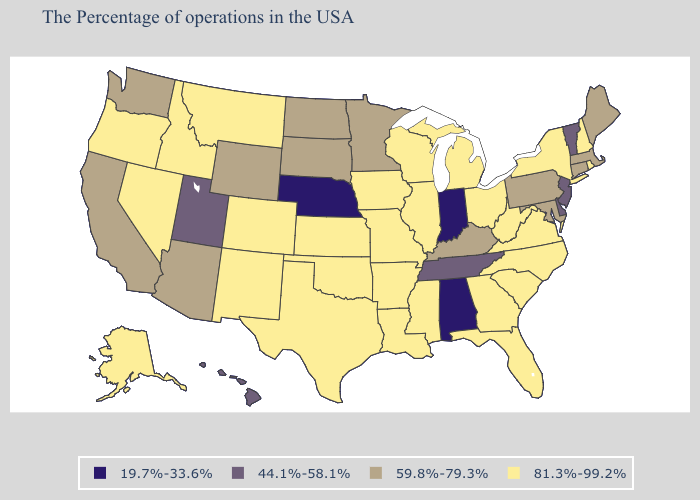Name the states that have a value in the range 59.8%-79.3%?
Keep it brief. Maine, Massachusetts, Connecticut, Maryland, Pennsylvania, Kentucky, Minnesota, South Dakota, North Dakota, Wyoming, Arizona, California, Washington. What is the highest value in states that border California?
Quick response, please. 81.3%-99.2%. Name the states that have a value in the range 44.1%-58.1%?
Be succinct. Vermont, New Jersey, Delaware, Tennessee, Utah, Hawaii. Does the first symbol in the legend represent the smallest category?
Be succinct. Yes. What is the value of Tennessee?
Be succinct. 44.1%-58.1%. Is the legend a continuous bar?
Concise answer only. No. Does the first symbol in the legend represent the smallest category?
Be succinct. Yes. Name the states that have a value in the range 19.7%-33.6%?
Short answer required. Indiana, Alabama, Nebraska. Name the states that have a value in the range 44.1%-58.1%?
Give a very brief answer. Vermont, New Jersey, Delaware, Tennessee, Utah, Hawaii. What is the value of Hawaii?
Keep it brief. 44.1%-58.1%. Does Utah have a higher value than Missouri?
Give a very brief answer. No. Does Kentucky have the highest value in the USA?
Concise answer only. No. Does Montana have the highest value in the West?
Concise answer only. Yes. Does Missouri have a lower value than Connecticut?
Give a very brief answer. No. Which states have the highest value in the USA?
Concise answer only. Rhode Island, New Hampshire, New York, Virginia, North Carolina, South Carolina, West Virginia, Ohio, Florida, Georgia, Michigan, Wisconsin, Illinois, Mississippi, Louisiana, Missouri, Arkansas, Iowa, Kansas, Oklahoma, Texas, Colorado, New Mexico, Montana, Idaho, Nevada, Oregon, Alaska. 